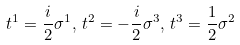<formula> <loc_0><loc_0><loc_500><loc_500>t ^ { 1 } = \frac { i } { 2 } \sigma ^ { 1 } , \, t ^ { 2 } = - \frac { i } { 2 } \sigma ^ { 3 } , \, t ^ { 3 } = \frac { 1 } { 2 } \sigma ^ { 2 }</formula> 